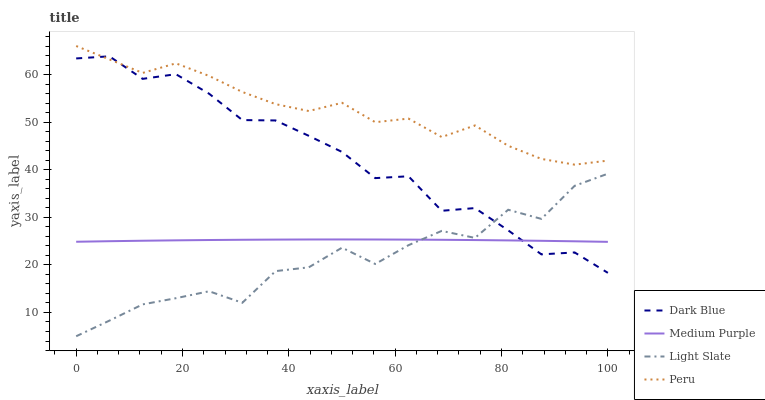Does Light Slate have the minimum area under the curve?
Answer yes or no. Yes. Does Peru have the maximum area under the curve?
Answer yes or no. Yes. Does Dark Blue have the minimum area under the curve?
Answer yes or no. No. Does Dark Blue have the maximum area under the curve?
Answer yes or no. No. Is Medium Purple the smoothest?
Answer yes or no. Yes. Is Light Slate the roughest?
Answer yes or no. Yes. Is Dark Blue the smoothest?
Answer yes or no. No. Is Dark Blue the roughest?
Answer yes or no. No. Does Light Slate have the lowest value?
Answer yes or no. Yes. Does Dark Blue have the lowest value?
Answer yes or no. No. Does Peru have the highest value?
Answer yes or no. Yes. Does Dark Blue have the highest value?
Answer yes or no. No. Is Light Slate less than Peru?
Answer yes or no. Yes. Is Peru greater than Light Slate?
Answer yes or no. Yes. Does Peru intersect Dark Blue?
Answer yes or no. Yes. Is Peru less than Dark Blue?
Answer yes or no. No. Is Peru greater than Dark Blue?
Answer yes or no. No. Does Light Slate intersect Peru?
Answer yes or no. No. 